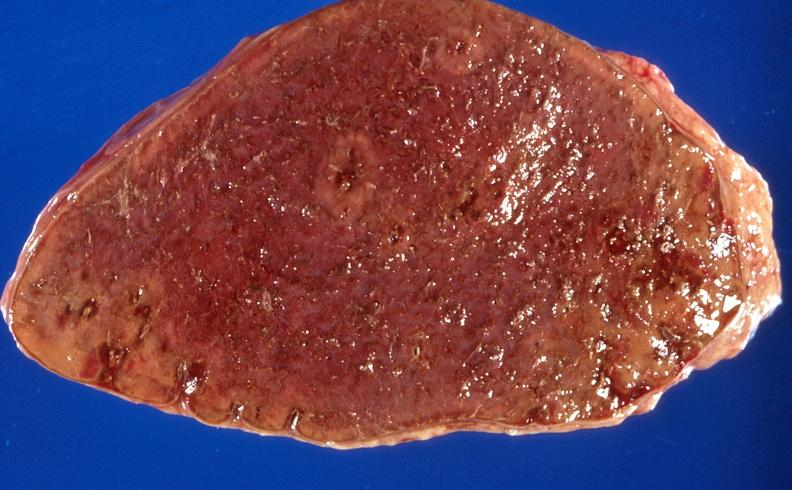what does this image show?
Answer the question using a single word or phrase. Sickle cell disease 